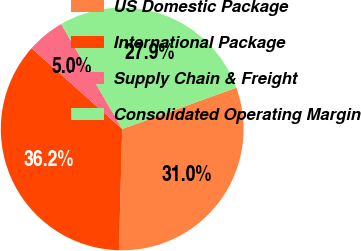<chart> <loc_0><loc_0><loc_500><loc_500><pie_chart><fcel>US Domestic Package<fcel>International Package<fcel>Supply Chain & Freight<fcel>Consolidated Operating Margin<nl><fcel>30.96%<fcel>36.16%<fcel>5.03%<fcel>27.85%<nl></chart> 